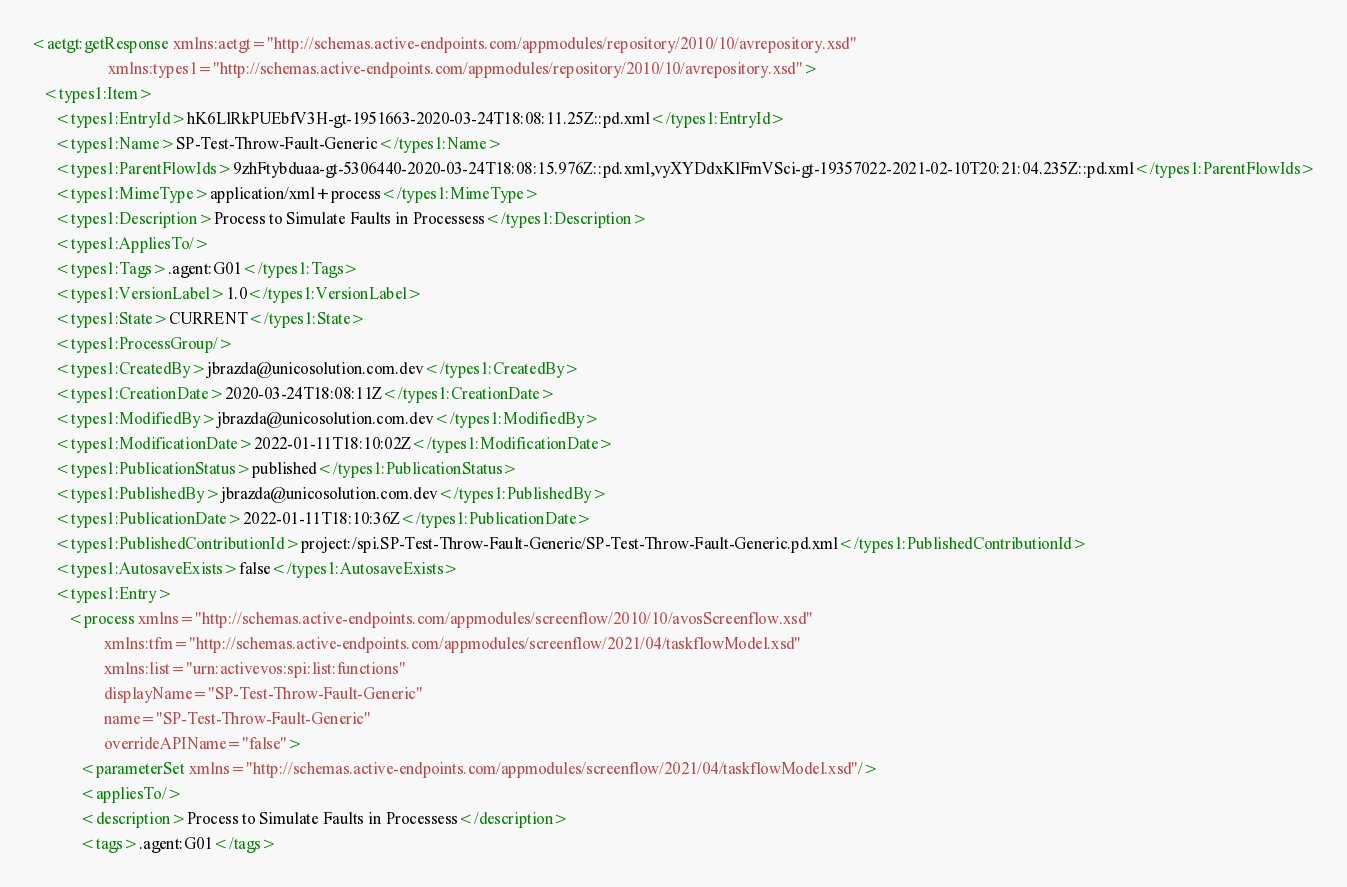Convert code to text. <code><loc_0><loc_0><loc_500><loc_500><_XML_><aetgt:getResponse xmlns:aetgt="http://schemas.active-endpoints.com/appmodules/repository/2010/10/avrepository.xsd"
                   xmlns:types1="http://schemas.active-endpoints.com/appmodules/repository/2010/10/avrepository.xsd">
   <types1:Item>
      <types1:EntryId>hK6LlRkPUEbfV3H-gt-1951663-2020-03-24T18:08:11.25Z::pd.xml</types1:EntryId>
      <types1:Name>SP-Test-Throw-Fault-Generic</types1:Name>
      <types1:ParentFlowIds>9zhFtybduaa-gt-5306440-2020-03-24T18:08:15.976Z::pd.xml,vyXYDdxKlFmVSci-gt-19357022-2021-02-10T20:21:04.235Z::pd.xml</types1:ParentFlowIds>
      <types1:MimeType>application/xml+process</types1:MimeType>
      <types1:Description>Process to Simulate Faults in Processess</types1:Description>
      <types1:AppliesTo/>
      <types1:Tags>.agent:G01</types1:Tags>
      <types1:VersionLabel>1.0</types1:VersionLabel>
      <types1:State>CURRENT</types1:State>
      <types1:ProcessGroup/>
      <types1:CreatedBy>jbrazda@unicosolution.com.dev</types1:CreatedBy>
      <types1:CreationDate>2020-03-24T18:08:11Z</types1:CreationDate>
      <types1:ModifiedBy>jbrazda@unicosolution.com.dev</types1:ModifiedBy>
      <types1:ModificationDate>2022-01-11T18:10:02Z</types1:ModificationDate>
      <types1:PublicationStatus>published</types1:PublicationStatus>
      <types1:PublishedBy>jbrazda@unicosolution.com.dev</types1:PublishedBy>
      <types1:PublicationDate>2022-01-11T18:10:36Z</types1:PublicationDate>
      <types1:PublishedContributionId>project:/spi.SP-Test-Throw-Fault-Generic/SP-Test-Throw-Fault-Generic.pd.xml</types1:PublishedContributionId>
      <types1:AutosaveExists>false</types1:AutosaveExists>
      <types1:Entry>
         <process xmlns="http://schemas.active-endpoints.com/appmodules/screenflow/2010/10/avosScreenflow.xsd"
                  xmlns:tfm="http://schemas.active-endpoints.com/appmodules/screenflow/2021/04/taskflowModel.xsd"
                  xmlns:list="urn:activevos:spi:list:functions"
                  displayName="SP-Test-Throw-Fault-Generic"
                  name="SP-Test-Throw-Fault-Generic"
                  overrideAPIName="false">
            <parameterSet xmlns="http://schemas.active-endpoints.com/appmodules/screenflow/2021/04/taskflowModel.xsd"/>
            <appliesTo/>
            <description>Process to Simulate Faults in Processess</description>
            <tags>.agent:G01</tags></code> 